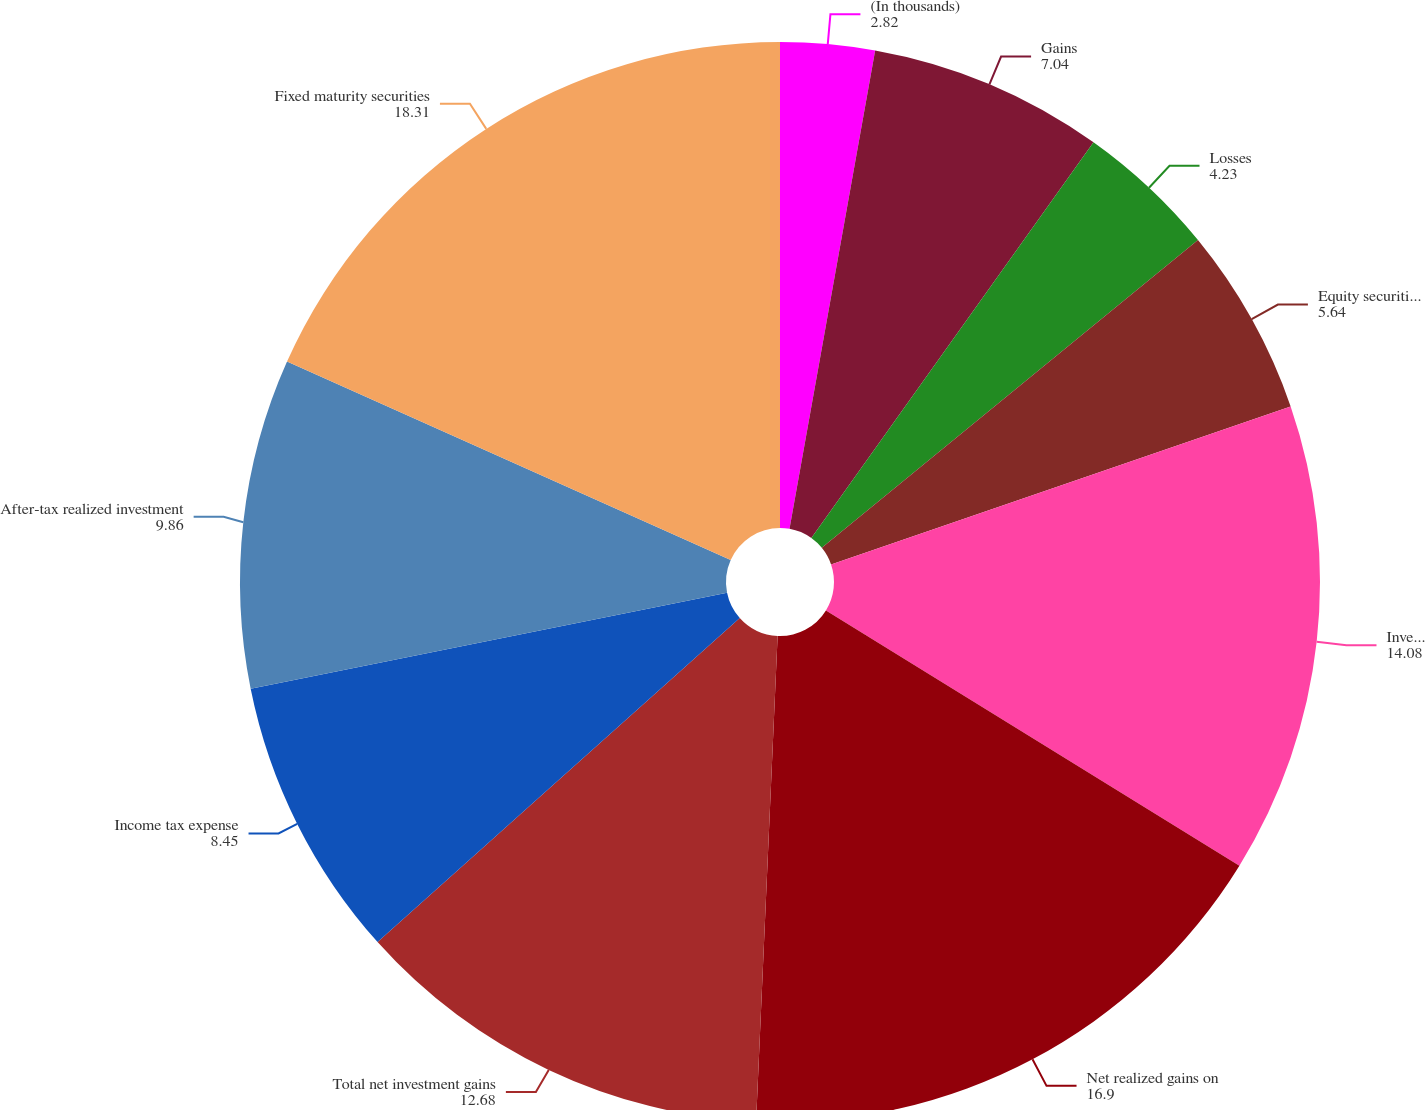Convert chart to OTSL. <chart><loc_0><loc_0><loc_500><loc_500><pie_chart><fcel>(In thousands)<fcel>Gains<fcel>Losses<fcel>Equity securities available<fcel>Investment funds<fcel>Net realized gains on<fcel>Total net investment gains<fcel>Income tax expense<fcel>After-tax realized investment<fcel>Fixed maturity securities<nl><fcel>2.82%<fcel>7.04%<fcel>4.23%<fcel>5.64%<fcel>14.08%<fcel>16.9%<fcel>12.68%<fcel>8.45%<fcel>9.86%<fcel>18.31%<nl></chart> 